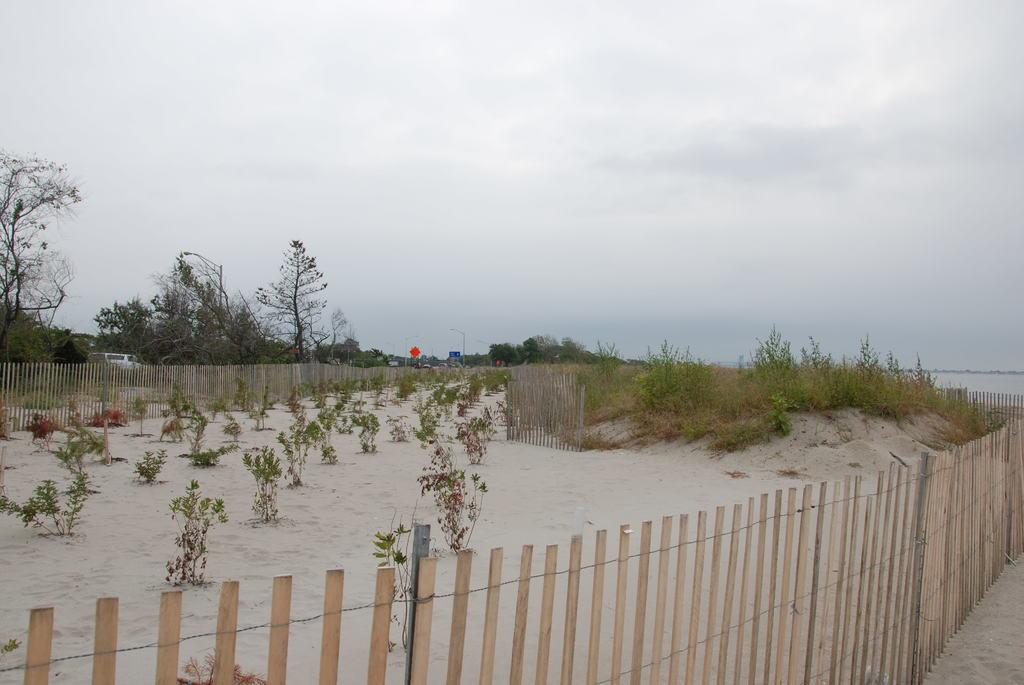What type of vegetation is present in the image? There are plants in the image. How are the plants situated in relation to other objects? The plants are between fences. What can be seen on the left side of the image? There are trees on the left side of the image. What is visible in the background of the image? The sky is visible in the background of the image. What type of linen can be seen draped over the plants in the image? There is no linen present in the image; it only features plants, fences, trees, and the sky. 